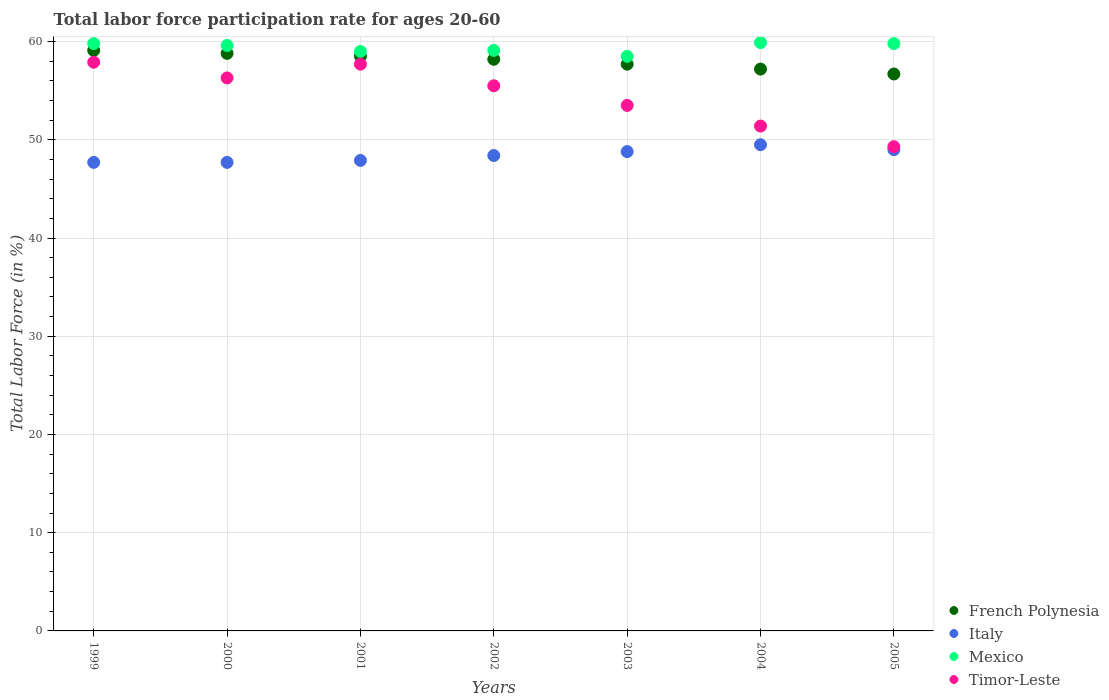How many different coloured dotlines are there?
Your response must be concise. 4. Is the number of dotlines equal to the number of legend labels?
Your response must be concise. Yes. What is the labor force participation rate in Mexico in 2000?
Make the answer very short. 59.6. Across all years, what is the maximum labor force participation rate in French Polynesia?
Offer a terse response. 59.1. Across all years, what is the minimum labor force participation rate in Timor-Leste?
Your answer should be very brief. 49.3. In which year was the labor force participation rate in Timor-Leste maximum?
Your answer should be very brief. 1999. What is the total labor force participation rate in Italy in the graph?
Ensure brevity in your answer.  339. What is the difference between the labor force participation rate in Italy in 1999 and that in 2001?
Offer a very short reply. -0.2. What is the difference between the labor force participation rate in French Polynesia in 2003 and the labor force participation rate in Mexico in 2001?
Keep it short and to the point. -1.3. What is the average labor force participation rate in Timor-Leste per year?
Ensure brevity in your answer.  54.51. In the year 2001, what is the difference between the labor force participation rate in Mexico and labor force participation rate in French Polynesia?
Your response must be concise. 0.5. What is the ratio of the labor force participation rate in French Polynesia in 2000 to that in 2003?
Keep it short and to the point. 1.02. Is the labor force participation rate in Timor-Leste in 2000 less than that in 2002?
Your answer should be very brief. No. What is the difference between the highest and the second highest labor force participation rate in French Polynesia?
Give a very brief answer. 0.3. What is the difference between the highest and the lowest labor force participation rate in Mexico?
Provide a succinct answer. 1.4. In how many years, is the labor force participation rate in French Polynesia greater than the average labor force participation rate in French Polynesia taken over all years?
Keep it short and to the point. 4. Is it the case that in every year, the sum of the labor force participation rate in Italy and labor force participation rate in Timor-Leste  is greater than the sum of labor force participation rate in French Polynesia and labor force participation rate in Mexico?
Provide a succinct answer. No. Does the labor force participation rate in French Polynesia monotonically increase over the years?
Your response must be concise. No. Is the labor force participation rate in Mexico strictly greater than the labor force participation rate in Timor-Leste over the years?
Offer a very short reply. Yes. How many years are there in the graph?
Your response must be concise. 7. Are the values on the major ticks of Y-axis written in scientific E-notation?
Give a very brief answer. No. Does the graph contain any zero values?
Your response must be concise. No. Does the graph contain grids?
Your answer should be compact. Yes. How many legend labels are there?
Provide a succinct answer. 4. What is the title of the graph?
Your answer should be compact. Total labor force participation rate for ages 20-60. Does "French Polynesia" appear as one of the legend labels in the graph?
Offer a terse response. Yes. What is the Total Labor Force (in %) in French Polynesia in 1999?
Make the answer very short. 59.1. What is the Total Labor Force (in %) of Italy in 1999?
Keep it short and to the point. 47.7. What is the Total Labor Force (in %) of Mexico in 1999?
Make the answer very short. 59.8. What is the Total Labor Force (in %) in Timor-Leste in 1999?
Your answer should be compact. 57.9. What is the Total Labor Force (in %) in French Polynesia in 2000?
Give a very brief answer. 58.8. What is the Total Labor Force (in %) of Italy in 2000?
Your answer should be very brief. 47.7. What is the Total Labor Force (in %) in Mexico in 2000?
Give a very brief answer. 59.6. What is the Total Labor Force (in %) of Timor-Leste in 2000?
Make the answer very short. 56.3. What is the Total Labor Force (in %) of French Polynesia in 2001?
Provide a succinct answer. 58.5. What is the Total Labor Force (in %) in Italy in 2001?
Your answer should be compact. 47.9. What is the Total Labor Force (in %) in Timor-Leste in 2001?
Provide a short and direct response. 57.7. What is the Total Labor Force (in %) of French Polynesia in 2002?
Your answer should be very brief. 58.2. What is the Total Labor Force (in %) in Italy in 2002?
Keep it short and to the point. 48.4. What is the Total Labor Force (in %) in Mexico in 2002?
Make the answer very short. 59.1. What is the Total Labor Force (in %) in Timor-Leste in 2002?
Make the answer very short. 55.5. What is the Total Labor Force (in %) in French Polynesia in 2003?
Your answer should be compact. 57.7. What is the Total Labor Force (in %) in Italy in 2003?
Make the answer very short. 48.8. What is the Total Labor Force (in %) in Mexico in 2003?
Your answer should be very brief. 58.5. What is the Total Labor Force (in %) in Timor-Leste in 2003?
Give a very brief answer. 53.5. What is the Total Labor Force (in %) of French Polynesia in 2004?
Make the answer very short. 57.2. What is the Total Labor Force (in %) of Italy in 2004?
Give a very brief answer. 49.5. What is the Total Labor Force (in %) in Mexico in 2004?
Make the answer very short. 59.9. What is the Total Labor Force (in %) in Timor-Leste in 2004?
Make the answer very short. 51.4. What is the Total Labor Force (in %) of French Polynesia in 2005?
Your answer should be compact. 56.7. What is the Total Labor Force (in %) of Italy in 2005?
Ensure brevity in your answer.  49. What is the Total Labor Force (in %) in Mexico in 2005?
Offer a very short reply. 59.8. What is the Total Labor Force (in %) in Timor-Leste in 2005?
Ensure brevity in your answer.  49.3. Across all years, what is the maximum Total Labor Force (in %) of French Polynesia?
Keep it short and to the point. 59.1. Across all years, what is the maximum Total Labor Force (in %) of Italy?
Your answer should be compact. 49.5. Across all years, what is the maximum Total Labor Force (in %) of Mexico?
Offer a terse response. 59.9. Across all years, what is the maximum Total Labor Force (in %) in Timor-Leste?
Your answer should be compact. 57.9. Across all years, what is the minimum Total Labor Force (in %) in French Polynesia?
Provide a succinct answer. 56.7. Across all years, what is the minimum Total Labor Force (in %) of Italy?
Ensure brevity in your answer.  47.7. Across all years, what is the minimum Total Labor Force (in %) in Mexico?
Give a very brief answer. 58.5. Across all years, what is the minimum Total Labor Force (in %) of Timor-Leste?
Your answer should be very brief. 49.3. What is the total Total Labor Force (in %) of French Polynesia in the graph?
Offer a terse response. 406.2. What is the total Total Labor Force (in %) of Italy in the graph?
Your response must be concise. 339. What is the total Total Labor Force (in %) in Mexico in the graph?
Offer a very short reply. 415.7. What is the total Total Labor Force (in %) in Timor-Leste in the graph?
Provide a short and direct response. 381.6. What is the difference between the Total Labor Force (in %) in Italy in 1999 and that in 2000?
Keep it short and to the point. 0. What is the difference between the Total Labor Force (in %) in Mexico in 1999 and that in 2000?
Ensure brevity in your answer.  0.2. What is the difference between the Total Labor Force (in %) in Timor-Leste in 1999 and that in 2000?
Offer a terse response. 1.6. What is the difference between the Total Labor Force (in %) of French Polynesia in 1999 and that in 2001?
Provide a succinct answer. 0.6. What is the difference between the Total Labor Force (in %) of French Polynesia in 1999 and that in 2002?
Offer a very short reply. 0.9. What is the difference between the Total Labor Force (in %) of Mexico in 1999 and that in 2003?
Ensure brevity in your answer.  1.3. What is the difference between the Total Labor Force (in %) of French Polynesia in 1999 and that in 2005?
Your response must be concise. 2.4. What is the difference between the Total Labor Force (in %) in Mexico in 1999 and that in 2005?
Your answer should be compact. 0. What is the difference between the Total Labor Force (in %) in Italy in 2000 and that in 2001?
Your answer should be very brief. -0.2. What is the difference between the Total Labor Force (in %) in Timor-Leste in 2000 and that in 2001?
Your answer should be very brief. -1.4. What is the difference between the Total Labor Force (in %) of Italy in 2000 and that in 2002?
Your answer should be compact. -0.7. What is the difference between the Total Labor Force (in %) of Mexico in 2000 and that in 2002?
Give a very brief answer. 0.5. What is the difference between the Total Labor Force (in %) of Timor-Leste in 2000 and that in 2002?
Your response must be concise. 0.8. What is the difference between the Total Labor Force (in %) of Timor-Leste in 2000 and that in 2003?
Provide a short and direct response. 2.8. What is the difference between the Total Labor Force (in %) in French Polynesia in 2000 and that in 2004?
Provide a succinct answer. 1.6. What is the difference between the Total Labor Force (in %) of Italy in 2000 and that in 2004?
Keep it short and to the point. -1.8. What is the difference between the Total Labor Force (in %) of Mexico in 2000 and that in 2004?
Offer a very short reply. -0.3. What is the difference between the Total Labor Force (in %) in Timor-Leste in 2000 and that in 2004?
Keep it short and to the point. 4.9. What is the difference between the Total Labor Force (in %) of French Polynesia in 2000 and that in 2005?
Your answer should be very brief. 2.1. What is the difference between the Total Labor Force (in %) in French Polynesia in 2001 and that in 2002?
Give a very brief answer. 0.3. What is the difference between the Total Labor Force (in %) in Italy in 2001 and that in 2002?
Provide a succinct answer. -0.5. What is the difference between the Total Labor Force (in %) in French Polynesia in 2001 and that in 2003?
Offer a terse response. 0.8. What is the difference between the Total Labor Force (in %) in Mexico in 2001 and that in 2003?
Make the answer very short. 0.5. What is the difference between the Total Labor Force (in %) in Italy in 2001 and that in 2004?
Your response must be concise. -1.6. What is the difference between the Total Labor Force (in %) of Timor-Leste in 2001 and that in 2004?
Keep it short and to the point. 6.3. What is the difference between the Total Labor Force (in %) of French Polynesia in 2001 and that in 2005?
Provide a short and direct response. 1.8. What is the difference between the Total Labor Force (in %) of Mexico in 2001 and that in 2005?
Provide a succinct answer. -0.8. What is the difference between the Total Labor Force (in %) in French Polynesia in 2002 and that in 2003?
Provide a succinct answer. 0.5. What is the difference between the Total Labor Force (in %) of Italy in 2002 and that in 2003?
Offer a very short reply. -0.4. What is the difference between the Total Labor Force (in %) of Timor-Leste in 2002 and that in 2003?
Ensure brevity in your answer.  2. What is the difference between the Total Labor Force (in %) in Mexico in 2002 and that in 2004?
Provide a succinct answer. -0.8. What is the difference between the Total Labor Force (in %) in French Polynesia in 2002 and that in 2005?
Give a very brief answer. 1.5. What is the difference between the Total Labor Force (in %) of Italy in 2002 and that in 2005?
Offer a very short reply. -0.6. What is the difference between the Total Labor Force (in %) in Italy in 2003 and that in 2004?
Offer a very short reply. -0.7. What is the difference between the Total Labor Force (in %) in Mexico in 2003 and that in 2004?
Your answer should be compact. -1.4. What is the difference between the Total Labor Force (in %) of Mexico in 2003 and that in 2005?
Ensure brevity in your answer.  -1.3. What is the difference between the Total Labor Force (in %) of French Polynesia in 2004 and that in 2005?
Your answer should be compact. 0.5. What is the difference between the Total Labor Force (in %) of Italy in 2004 and that in 2005?
Keep it short and to the point. 0.5. What is the difference between the Total Labor Force (in %) of Mexico in 2004 and that in 2005?
Provide a succinct answer. 0.1. What is the difference between the Total Labor Force (in %) in French Polynesia in 1999 and the Total Labor Force (in %) in Italy in 2000?
Keep it short and to the point. 11.4. What is the difference between the Total Labor Force (in %) in French Polynesia in 1999 and the Total Labor Force (in %) in Timor-Leste in 2000?
Provide a short and direct response. 2.8. What is the difference between the Total Labor Force (in %) in Mexico in 1999 and the Total Labor Force (in %) in Timor-Leste in 2001?
Offer a very short reply. 2.1. What is the difference between the Total Labor Force (in %) in French Polynesia in 1999 and the Total Labor Force (in %) in Italy in 2002?
Give a very brief answer. 10.7. What is the difference between the Total Labor Force (in %) in French Polynesia in 1999 and the Total Labor Force (in %) in Mexico in 2002?
Keep it short and to the point. 0. What is the difference between the Total Labor Force (in %) of French Polynesia in 1999 and the Total Labor Force (in %) of Timor-Leste in 2002?
Your response must be concise. 3.6. What is the difference between the Total Labor Force (in %) in Italy in 1999 and the Total Labor Force (in %) in Mexico in 2002?
Provide a short and direct response. -11.4. What is the difference between the Total Labor Force (in %) of Italy in 1999 and the Total Labor Force (in %) of Timor-Leste in 2002?
Your answer should be compact. -7.8. What is the difference between the Total Labor Force (in %) of French Polynesia in 1999 and the Total Labor Force (in %) of Timor-Leste in 2003?
Give a very brief answer. 5.6. What is the difference between the Total Labor Force (in %) of Mexico in 1999 and the Total Labor Force (in %) of Timor-Leste in 2003?
Your answer should be compact. 6.3. What is the difference between the Total Labor Force (in %) in French Polynesia in 1999 and the Total Labor Force (in %) in Mexico in 2004?
Offer a terse response. -0.8. What is the difference between the Total Labor Force (in %) in French Polynesia in 1999 and the Total Labor Force (in %) in Timor-Leste in 2004?
Your response must be concise. 7.7. What is the difference between the Total Labor Force (in %) in Italy in 1999 and the Total Labor Force (in %) in Timor-Leste in 2004?
Provide a short and direct response. -3.7. What is the difference between the Total Labor Force (in %) in Mexico in 1999 and the Total Labor Force (in %) in Timor-Leste in 2004?
Offer a terse response. 8.4. What is the difference between the Total Labor Force (in %) in French Polynesia in 1999 and the Total Labor Force (in %) in Italy in 2005?
Provide a succinct answer. 10.1. What is the difference between the Total Labor Force (in %) in French Polynesia in 1999 and the Total Labor Force (in %) in Mexico in 2005?
Your answer should be compact. -0.7. What is the difference between the Total Labor Force (in %) of Italy in 1999 and the Total Labor Force (in %) of Mexico in 2005?
Make the answer very short. -12.1. What is the difference between the Total Labor Force (in %) in Italy in 1999 and the Total Labor Force (in %) in Timor-Leste in 2005?
Ensure brevity in your answer.  -1.6. What is the difference between the Total Labor Force (in %) in French Polynesia in 2000 and the Total Labor Force (in %) in Mexico in 2001?
Offer a terse response. -0.2. What is the difference between the Total Labor Force (in %) of French Polynesia in 2000 and the Total Labor Force (in %) of Timor-Leste in 2001?
Make the answer very short. 1.1. What is the difference between the Total Labor Force (in %) in Italy in 2000 and the Total Labor Force (in %) in Mexico in 2001?
Your response must be concise. -11.3. What is the difference between the Total Labor Force (in %) in Italy in 2000 and the Total Labor Force (in %) in Timor-Leste in 2001?
Provide a succinct answer. -10. What is the difference between the Total Labor Force (in %) in French Polynesia in 2000 and the Total Labor Force (in %) in Italy in 2002?
Your response must be concise. 10.4. What is the difference between the Total Labor Force (in %) in French Polynesia in 2000 and the Total Labor Force (in %) in Mexico in 2002?
Offer a terse response. -0.3. What is the difference between the Total Labor Force (in %) of French Polynesia in 2000 and the Total Labor Force (in %) of Timor-Leste in 2002?
Your answer should be very brief. 3.3. What is the difference between the Total Labor Force (in %) in Italy in 2000 and the Total Labor Force (in %) in Mexico in 2002?
Your answer should be compact. -11.4. What is the difference between the Total Labor Force (in %) of Italy in 2000 and the Total Labor Force (in %) of Timor-Leste in 2002?
Your response must be concise. -7.8. What is the difference between the Total Labor Force (in %) in French Polynesia in 2000 and the Total Labor Force (in %) in Mexico in 2003?
Offer a very short reply. 0.3. What is the difference between the Total Labor Force (in %) of Mexico in 2000 and the Total Labor Force (in %) of Timor-Leste in 2003?
Offer a terse response. 6.1. What is the difference between the Total Labor Force (in %) of French Polynesia in 2000 and the Total Labor Force (in %) of Italy in 2004?
Your response must be concise. 9.3. What is the difference between the Total Labor Force (in %) of French Polynesia in 2000 and the Total Labor Force (in %) of Timor-Leste in 2004?
Provide a short and direct response. 7.4. What is the difference between the Total Labor Force (in %) in Italy in 2000 and the Total Labor Force (in %) in Mexico in 2004?
Your answer should be very brief. -12.2. What is the difference between the Total Labor Force (in %) of Mexico in 2000 and the Total Labor Force (in %) of Timor-Leste in 2004?
Provide a succinct answer. 8.2. What is the difference between the Total Labor Force (in %) in French Polynesia in 2000 and the Total Labor Force (in %) in Italy in 2005?
Offer a very short reply. 9.8. What is the difference between the Total Labor Force (in %) in French Polynesia in 2000 and the Total Labor Force (in %) in Mexico in 2005?
Make the answer very short. -1. What is the difference between the Total Labor Force (in %) in Italy in 2000 and the Total Labor Force (in %) in Timor-Leste in 2005?
Your answer should be very brief. -1.6. What is the difference between the Total Labor Force (in %) in French Polynesia in 2001 and the Total Labor Force (in %) in Italy in 2002?
Offer a terse response. 10.1. What is the difference between the Total Labor Force (in %) of French Polynesia in 2001 and the Total Labor Force (in %) of Mexico in 2002?
Your answer should be compact. -0.6. What is the difference between the Total Labor Force (in %) in French Polynesia in 2001 and the Total Labor Force (in %) in Timor-Leste in 2002?
Your answer should be very brief. 3. What is the difference between the Total Labor Force (in %) in French Polynesia in 2001 and the Total Labor Force (in %) in Mexico in 2003?
Your answer should be compact. 0. What is the difference between the Total Labor Force (in %) of French Polynesia in 2001 and the Total Labor Force (in %) of Timor-Leste in 2003?
Your answer should be very brief. 5. What is the difference between the Total Labor Force (in %) of Italy in 2001 and the Total Labor Force (in %) of Timor-Leste in 2003?
Provide a short and direct response. -5.6. What is the difference between the Total Labor Force (in %) of Mexico in 2001 and the Total Labor Force (in %) of Timor-Leste in 2003?
Provide a succinct answer. 5.5. What is the difference between the Total Labor Force (in %) of French Polynesia in 2001 and the Total Labor Force (in %) of Italy in 2004?
Your response must be concise. 9. What is the difference between the Total Labor Force (in %) of French Polynesia in 2001 and the Total Labor Force (in %) of Mexico in 2004?
Give a very brief answer. -1.4. What is the difference between the Total Labor Force (in %) of Italy in 2001 and the Total Labor Force (in %) of Mexico in 2004?
Ensure brevity in your answer.  -12. What is the difference between the Total Labor Force (in %) in French Polynesia in 2001 and the Total Labor Force (in %) in Timor-Leste in 2005?
Offer a terse response. 9.2. What is the difference between the Total Labor Force (in %) in Italy in 2001 and the Total Labor Force (in %) in Mexico in 2005?
Offer a very short reply. -11.9. What is the difference between the Total Labor Force (in %) of Mexico in 2001 and the Total Labor Force (in %) of Timor-Leste in 2005?
Ensure brevity in your answer.  9.7. What is the difference between the Total Labor Force (in %) of French Polynesia in 2002 and the Total Labor Force (in %) of Italy in 2003?
Make the answer very short. 9.4. What is the difference between the Total Labor Force (in %) in French Polynesia in 2002 and the Total Labor Force (in %) in Mexico in 2003?
Your response must be concise. -0.3. What is the difference between the Total Labor Force (in %) in French Polynesia in 2002 and the Total Labor Force (in %) in Timor-Leste in 2003?
Give a very brief answer. 4.7. What is the difference between the Total Labor Force (in %) of Italy in 2002 and the Total Labor Force (in %) of Mexico in 2003?
Keep it short and to the point. -10.1. What is the difference between the Total Labor Force (in %) of Mexico in 2002 and the Total Labor Force (in %) of Timor-Leste in 2003?
Make the answer very short. 5.6. What is the difference between the Total Labor Force (in %) of French Polynesia in 2002 and the Total Labor Force (in %) of Mexico in 2004?
Your answer should be very brief. -1.7. What is the difference between the Total Labor Force (in %) in French Polynesia in 2002 and the Total Labor Force (in %) in Timor-Leste in 2004?
Provide a short and direct response. 6.8. What is the difference between the Total Labor Force (in %) of Italy in 2002 and the Total Labor Force (in %) of Mexico in 2004?
Ensure brevity in your answer.  -11.5. What is the difference between the Total Labor Force (in %) of Italy in 2002 and the Total Labor Force (in %) of Timor-Leste in 2004?
Make the answer very short. -3. What is the difference between the Total Labor Force (in %) in Mexico in 2002 and the Total Labor Force (in %) in Timor-Leste in 2004?
Offer a terse response. 7.7. What is the difference between the Total Labor Force (in %) in French Polynesia in 2002 and the Total Labor Force (in %) in Mexico in 2005?
Provide a short and direct response. -1.6. What is the difference between the Total Labor Force (in %) in French Polynesia in 2002 and the Total Labor Force (in %) in Timor-Leste in 2005?
Offer a terse response. 8.9. What is the difference between the Total Labor Force (in %) of Italy in 2002 and the Total Labor Force (in %) of Mexico in 2005?
Offer a terse response. -11.4. What is the difference between the Total Labor Force (in %) in Italy in 2002 and the Total Labor Force (in %) in Timor-Leste in 2005?
Provide a succinct answer. -0.9. What is the difference between the Total Labor Force (in %) in Mexico in 2002 and the Total Labor Force (in %) in Timor-Leste in 2005?
Your answer should be compact. 9.8. What is the difference between the Total Labor Force (in %) of French Polynesia in 2003 and the Total Labor Force (in %) of Timor-Leste in 2004?
Your answer should be very brief. 6.3. What is the difference between the Total Labor Force (in %) in Italy in 2003 and the Total Labor Force (in %) in Mexico in 2004?
Give a very brief answer. -11.1. What is the difference between the Total Labor Force (in %) of Italy in 2003 and the Total Labor Force (in %) of Timor-Leste in 2004?
Provide a succinct answer. -2.6. What is the difference between the Total Labor Force (in %) in Mexico in 2003 and the Total Labor Force (in %) in Timor-Leste in 2004?
Offer a very short reply. 7.1. What is the difference between the Total Labor Force (in %) of French Polynesia in 2003 and the Total Labor Force (in %) of Italy in 2005?
Your response must be concise. 8.7. What is the difference between the Total Labor Force (in %) of French Polynesia in 2003 and the Total Labor Force (in %) of Timor-Leste in 2005?
Give a very brief answer. 8.4. What is the difference between the Total Labor Force (in %) of Italy in 2003 and the Total Labor Force (in %) of Mexico in 2005?
Your response must be concise. -11. What is the difference between the Total Labor Force (in %) of Mexico in 2004 and the Total Labor Force (in %) of Timor-Leste in 2005?
Provide a short and direct response. 10.6. What is the average Total Labor Force (in %) of French Polynesia per year?
Offer a very short reply. 58.03. What is the average Total Labor Force (in %) of Italy per year?
Offer a very short reply. 48.43. What is the average Total Labor Force (in %) of Mexico per year?
Offer a terse response. 59.39. What is the average Total Labor Force (in %) in Timor-Leste per year?
Keep it short and to the point. 54.51. In the year 1999, what is the difference between the Total Labor Force (in %) in French Polynesia and Total Labor Force (in %) in Italy?
Your answer should be compact. 11.4. In the year 1999, what is the difference between the Total Labor Force (in %) of French Polynesia and Total Labor Force (in %) of Mexico?
Offer a very short reply. -0.7. In the year 1999, what is the difference between the Total Labor Force (in %) in French Polynesia and Total Labor Force (in %) in Timor-Leste?
Offer a terse response. 1.2. In the year 1999, what is the difference between the Total Labor Force (in %) of Italy and Total Labor Force (in %) of Timor-Leste?
Your answer should be very brief. -10.2. In the year 1999, what is the difference between the Total Labor Force (in %) of Mexico and Total Labor Force (in %) of Timor-Leste?
Make the answer very short. 1.9. In the year 2000, what is the difference between the Total Labor Force (in %) in French Polynesia and Total Labor Force (in %) in Italy?
Give a very brief answer. 11.1. In the year 2000, what is the difference between the Total Labor Force (in %) in French Polynesia and Total Labor Force (in %) in Timor-Leste?
Offer a terse response. 2.5. In the year 2000, what is the difference between the Total Labor Force (in %) in Mexico and Total Labor Force (in %) in Timor-Leste?
Give a very brief answer. 3.3. In the year 2001, what is the difference between the Total Labor Force (in %) in French Polynesia and Total Labor Force (in %) in Italy?
Offer a very short reply. 10.6. In the year 2001, what is the difference between the Total Labor Force (in %) of French Polynesia and Total Labor Force (in %) of Timor-Leste?
Provide a succinct answer. 0.8. In the year 2001, what is the difference between the Total Labor Force (in %) in Italy and Total Labor Force (in %) in Mexico?
Your answer should be very brief. -11.1. In the year 2001, what is the difference between the Total Labor Force (in %) in Mexico and Total Labor Force (in %) in Timor-Leste?
Provide a succinct answer. 1.3. In the year 2002, what is the difference between the Total Labor Force (in %) of French Polynesia and Total Labor Force (in %) of Italy?
Ensure brevity in your answer.  9.8. In the year 2002, what is the difference between the Total Labor Force (in %) in French Polynesia and Total Labor Force (in %) in Mexico?
Give a very brief answer. -0.9. In the year 2002, what is the difference between the Total Labor Force (in %) of French Polynesia and Total Labor Force (in %) of Timor-Leste?
Make the answer very short. 2.7. In the year 2002, what is the difference between the Total Labor Force (in %) in Italy and Total Labor Force (in %) in Mexico?
Offer a terse response. -10.7. In the year 2002, what is the difference between the Total Labor Force (in %) of Italy and Total Labor Force (in %) of Timor-Leste?
Provide a short and direct response. -7.1. In the year 2003, what is the difference between the Total Labor Force (in %) in French Polynesia and Total Labor Force (in %) in Italy?
Your answer should be compact. 8.9. In the year 2003, what is the difference between the Total Labor Force (in %) in French Polynesia and Total Labor Force (in %) in Mexico?
Your response must be concise. -0.8. In the year 2003, what is the difference between the Total Labor Force (in %) of French Polynesia and Total Labor Force (in %) of Timor-Leste?
Make the answer very short. 4.2. In the year 2003, what is the difference between the Total Labor Force (in %) in Italy and Total Labor Force (in %) in Timor-Leste?
Your response must be concise. -4.7. In the year 2003, what is the difference between the Total Labor Force (in %) in Mexico and Total Labor Force (in %) in Timor-Leste?
Provide a succinct answer. 5. In the year 2004, what is the difference between the Total Labor Force (in %) of French Polynesia and Total Labor Force (in %) of Italy?
Provide a short and direct response. 7.7. In the year 2004, what is the difference between the Total Labor Force (in %) of French Polynesia and Total Labor Force (in %) of Mexico?
Your answer should be very brief. -2.7. In the year 2004, what is the difference between the Total Labor Force (in %) of Italy and Total Labor Force (in %) of Mexico?
Keep it short and to the point. -10.4. In the year 2005, what is the difference between the Total Labor Force (in %) of French Polynesia and Total Labor Force (in %) of Italy?
Make the answer very short. 7.7. In the year 2005, what is the difference between the Total Labor Force (in %) of French Polynesia and Total Labor Force (in %) of Timor-Leste?
Your answer should be very brief. 7.4. In the year 2005, what is the difference between the Total Labor Force (in %) of Italy and Total Labor Force (in %) of Timor-Leste?
Your answer should be compact. -0.3. What is the ratio of the Total Labor Force (in %) of French Polynesia in 1999 to that in 2000?
Give a very brief answer. 1.01. What is the ratio of the Total Labor Force (in %) of Mexico in 1999 to that in 2000?
Your answer should be very brief. 1. What is the ratio of the Total Labor Force (in %) in Timor-Leste in 1999 to that in 2000?
Make the answer very short. 1.03. What is the ratio of the Total Labor Force (in %) in French Polynesia in 1999 to that in 2001?
Ensure brevity in your answer.  1.01. What is the ratio of the Total Labor Force (in %) in Mexico in 1999 to that in 2001?
Provide a succinct answer. 1.01. What is the ratio of the Total Labor Force (in %) in French Polynesia in 1999 to that in 2002?
Provide a short and direct response. 1.02. What is the ratio of the Total Labor Force (in %) of Italy in 1999 to that in 2002?
Your answer should be very brief. 0.99. What is the ratio of the Total Labor Force (in %) in Mexico in 1999 to that in 2002?
Make the answer very short. 1.01. What is the ratio of the Total Labor Force (in %) of Timor-Leste in 1999 to that in 2002?
Offer a very short reply. 1.04. What is the ratio of the Total Labor Force (in %) of French Polynesia in 1999 to that in 2003?
Offer a terse response. 1.02. What is the ratio of the Total Labor Force (in %) in Italy in 1999 to that in 2003?
Your answer should be compact. 0.98. What is the ratio of the Total Labor Force (in %) of Mexico in 1999 to that in 2003?
Your response must be concise. 1.02. What is the ratio of the Total Labor Force (in %) of Timor-Leste in 1999 to that in 2003?
Ensure brevity in your answer.  1.08. What is the ratio of the Total Labor Force (in %) in French Polynesia in 1999 to that in 2004?
Provide a short and direct response. 1.03. What is the ratio of the Total Labor Force (in %) of Italy in 1999 to that in 2004?
Keep it short and to the point. 0.96. What is the ratio of the Total Labor Force (in %) in Timor-Leste in 1999 to that in 2004?
Your response must be concise. 1.13. What is the ratio of the Total Labor Force (in %) of French Polynesia in 1999 to that in 2005?
Offer a very short reply. 1.04. What is the ratio of the Total Labor Force (in %) of Italy in 1999 to that in 2005?
Provide a succinct answer. 0.97. What is the ratio of the Total Labor Force (in %) of Mexico in 1999 to that in 2005?
Your answer should be compact. 1. What is the ratio of the Total Labor Force (in %) of Timor-Leste in 1999 to that in 2005?
Provide a succinct answer. 1.17. What is the ratio of the Total Labor Force (in %) in Italy in 2000 to that in 2001?
Provide a succinct answer. 1. What is the ratio of the Total Labor Force (in %) in Mexico in 2000 to that in 2001?
Your answer should be compact. 1.01. What is the ratio of the Total Labor Force (in %) in Timor-Leste in 2000 to that in 2001?
Keep it short and to the point. 0.98. What is the ratio of the Total Labor Force (in %) of French Polynesia in 2000 to that in 2002?
Offer a very short reply. 1.01. What is the ratio of the Total Labor Force (in %) of Italy in 2000 to that in 2002?
Give a very brief answer. 0.99. What is the ratio of the Total Labor Force (in %) of Mexico in 2000 to that in 2002?
Offer a very short reply. 1.01. What is the ratio of the Total Labor Force (in %) of Timor-Leste in 2000 to that in 2002?
Provide a short and direct response. 1.01. What is the ratio of the Total Labor Force (in %) in French Polynesia in 2000 to that in 2003?
Offer a very short reply. 1.02. What is the ratio of the Total Labor Force (in %) of Italy in 2000 to that in 2003?
Provide a succinct answer. 0.98. What is the ratio of the Total Labor Force (in %) of Mexico in 2000 to that in 2003?
Make the answer very short. 1.02. What is the ratio of the Total Labor Force (in %) in Timor-Leste in 2000 to that in 2003?
Offer a terse response. 1.05. What is the ratio of the Total Labor Force (in %) in French Polynesia in 2000 to that in 2004?
Ensure brevity in your answer.  1.03. What is the ratio of the Total Labor Force (in %) of Italy in 2000 to that in 2004?
Offer a very short reply. 0.96. What is the ratio of the Total Labor Force (in %) in Timor-Leste in 2000 to that in 2004?
Make the answer very short. 1.1. What is the ratio of the Total Labor Force (in %) in French Polynesia in 2000 to that in 2005?
Give a very brief answer. 1.04. What is the ratio of the Total Labor Force (in %) in Italy in 2000 to that in 2005?
Offer a terse response. 0.97. What is the ratio of the Total Labor Force (in %) in Timor-Leste in 2000 to that in 2005?
Provide a short and direct response. 1.14. What is the ratio of the Total Labor Force (in %) in French Polynesia in 2001 to that in 2002?
Keep it short and to the point. 1.01. What is the ratio of the Total Labor Force (in %) of Mexico in 2001 to that in 2002?
Give a very brief answer. 1. What is the ratio of the Total Labor Force (in %) in Timor-Leste in 2001 to that in 2002?
Offer a terse response. 1.04. What is the ratio of the Total Labor Force (in %) of French Polynesia in 2001 to that in 2003?
Offer a very short reply. 1.01. What is the ratio of the Total Labor Force (in %) of Italy in 2001 to that in 2003?
Ensure brevity in your answer.  0.98. What is the ratio of the Total Labor Force (in %) in Mexico in 2001 to that in 2003?
Provide a succinct answer. 1.01. What is the ratio of the Total Labor Force (in %) in Timor-Leste in 2001 to that in 2003?
Give a very brief answer. 1.08. What is the ratio of the Total Labor Force (in %) in French Polynesia in 2001 to that in 2004?
Your answer should be compact. 1.02. What is the ratio of the Total Labor Force (in %) in Italy in 2001 to that in 2004?
Keep it short and to the point. 0.97. What is the ratio of the Total Labor Force (in %) in Timor-Leste in 2001 to that in 2004?
Offer a terse response. 1.12. What is the ratio of the Total Labor Force (in %) of French Polynesia in 2001 to that in 2005?
Give a very brief answer. 1.03. What is the ratio of the Total Labor Force (in %) in Italy in 2001 to that in 2005?
Your response must be concise. 0.98. What is the ratio of the Total Labor Force (in %) in Mexico in 2001 to that in 2005?
Your response must be concise. 0.99. What is the ratio of the Total Labor Force (in %) in Timor-Leste in 2001 to that in 2005?
Your response must be concise. 1.17. What is the ratio of the Total Labor Force (in %) of French Polynesia in 2002 to that in 2003?
Make the answer very short. 1.01. What is the ratio of the Total Labor Force (in %) of Mexico in 2002 to that in 2003?
Provide a succinct answer. 1.01. What is the ratio of the Total Labor Force (in %) in Timor-Leste in 2002 to that in 2003?
Provide a short and direct response. 1.04. What is the ratio of the Total Labor Force (in %) in French Polynesia in 2002 to that in 2004?
Your response must be concise. 1.02. What is the ratio of the Total Labor Force (in %) in Italy in 2002 to that in 2004?
Provide a short and direct response. 0.98. What is the ratio of the Total Labor Force (in %) in Mexico in 2002 to that in 2004?
Your answer should be compact. 0.99. What is the ratio of the Total Labor Force (in %) of Timor-Leste in 2002 to that in 2004?
Provide a succinct answer. 1.08. What is the ratio of the Total Labor Force (in %) in French Polynesia in 2002 to that in 2005?
Offer a terse response. 1.03. What is the ratio of the Total Labor Force (in %) in Italy in 2002 to that in 2005?
Your answer should be very brief. 0.99. What is the ratio of the Total Labor Force (in %) of Mexico in 2002 to that in 2005?
Keep it short and to the point. 0.99. What is the ratio of the Total Labor Force (in %) in Timor-Leste in 2002 to that in 2005?
Offer a terse response. 1.13. What is the ratio of the Total Labor Force (in %) in French Polynesia in 2003 to that in 2004?
Your answer should be very brief. 1.01. What is the ratio of the Total Labor Force (in %) in Italy in 2003 to that in 2004?
Make the answer very short. 0.99. What is the ratio of the Total Labor Force (in %) in Mexico in 2003 to that in 2004?
Keep it short and to the point. 0.98. What is the ratio of the Total Labor Force (in %) of Timor-Leste in 2003 to that in 2004?
Your answer should be compact. 1.04. What is the ratio of the Total Labor Force (in %) of French Polynesia in 2003 to that in 2005?
Provide a short and direct response. 1.02. What is the ratio of the Total Labor Force (in %) of Mexico in 2003 to that in 2005?
Give a very brief answer. 0.98. What is the ratio of the Total Labor Force (in %) in Timor-Leste in 2003 to that in 2005?
Give a very brief answer. 1.09. What is the ratio of the Total Labor Force (in %) of French Polynesia in 2004 to that in 2005?
Your answer should be compact. 1.01. What is the ratio of the Total Labor Force (in %) of Italy in 2004 to that in 2005?
Offer a very short reply. 1.01. What is the ratio of the Total Labor Force (in %) in Mexico in 2004 to that in 2005?
Provide a succinct answer. 1. What is the ratio of the Total Labor Force (in %) in Timor-Leste in 2004 to that in 2005?
Your response must be concise. 1.04. What is the difference between the highest and the second highest Total Labor Force (in %) in Italy?
Offer a very short reply. 0.5. What is the difference between the highest and the lowest Total Labor Force (in %) in French Polynesia?
Your answer should be compact. 2.4. What is the difference between the highest and the lowest Total Labor Force (in %) of Italy?
Offer a very short reply. 1.8. What is the difference between the highest and the lowest Total Labor Force (in %) in Mexico?
Your response must be concise. 1.4. 